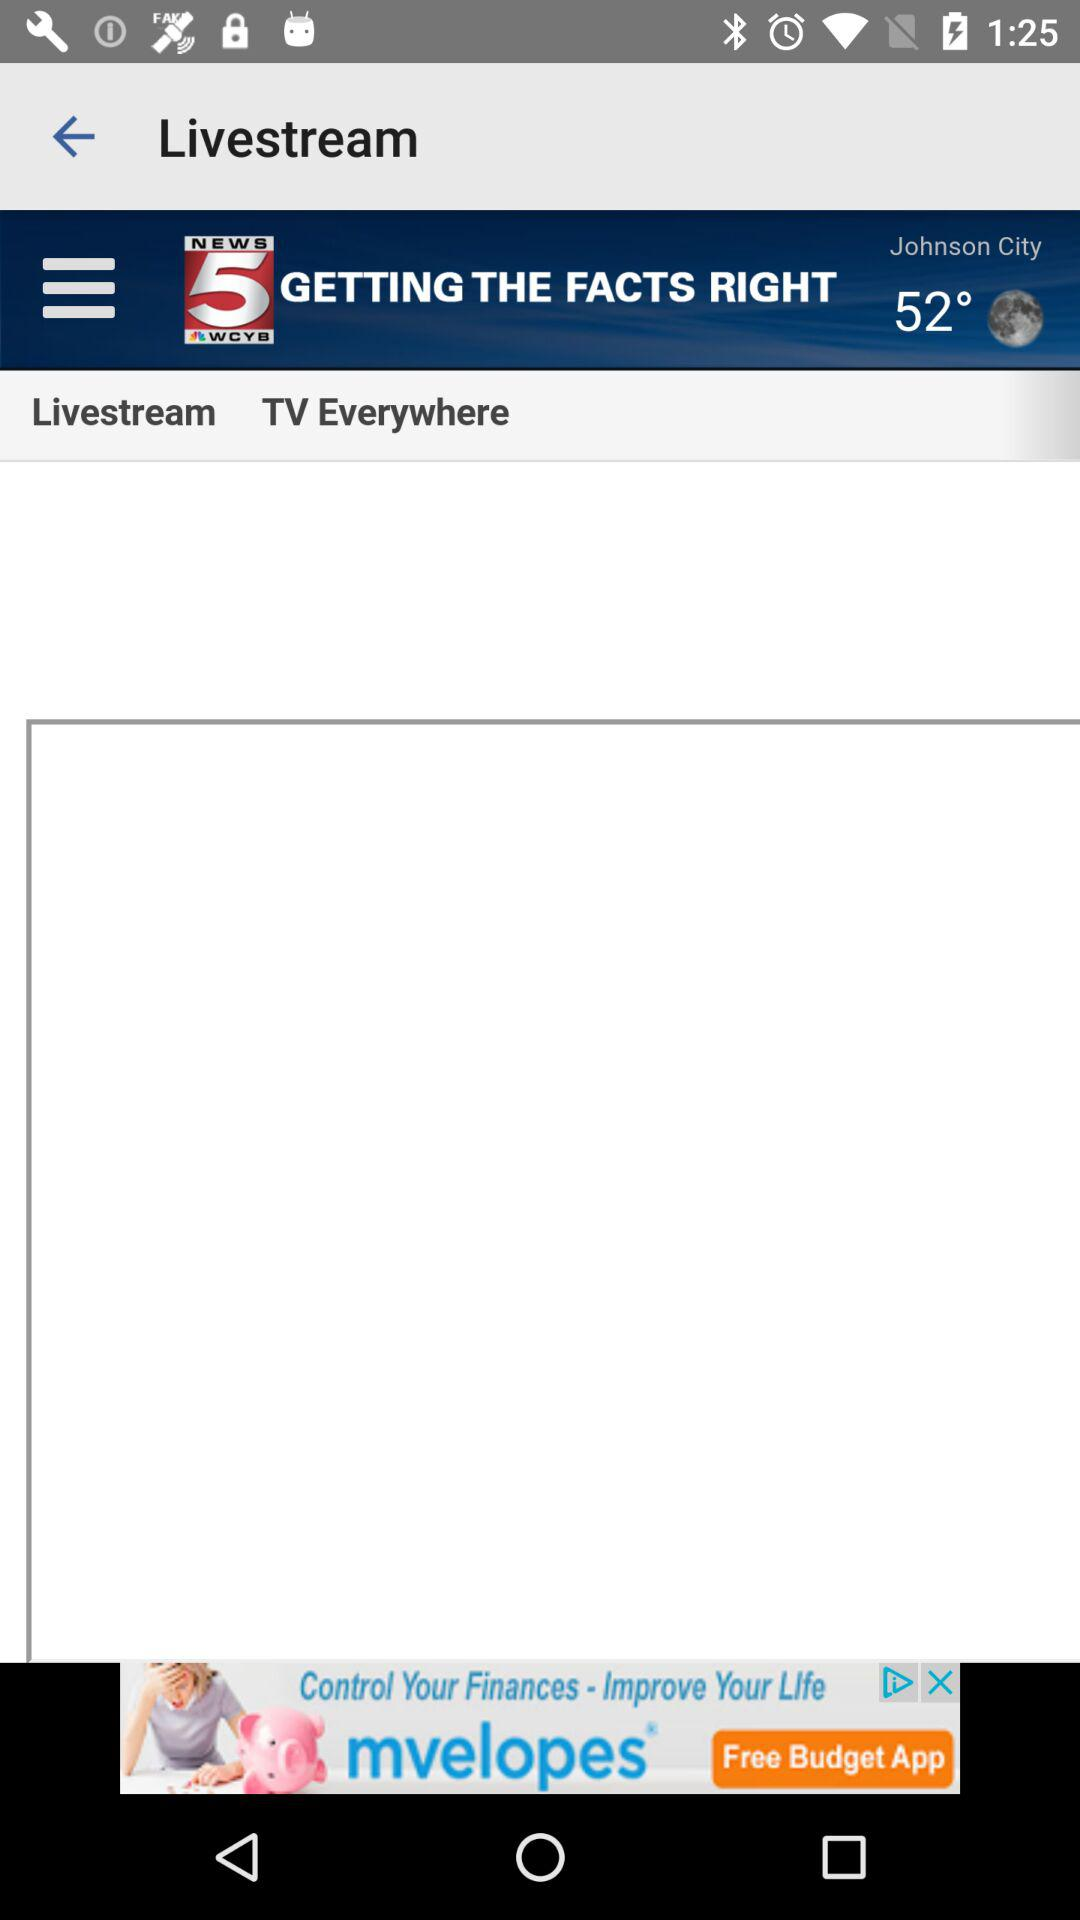What is the television station name? The television station name is "NEWS 5 WCYB". 